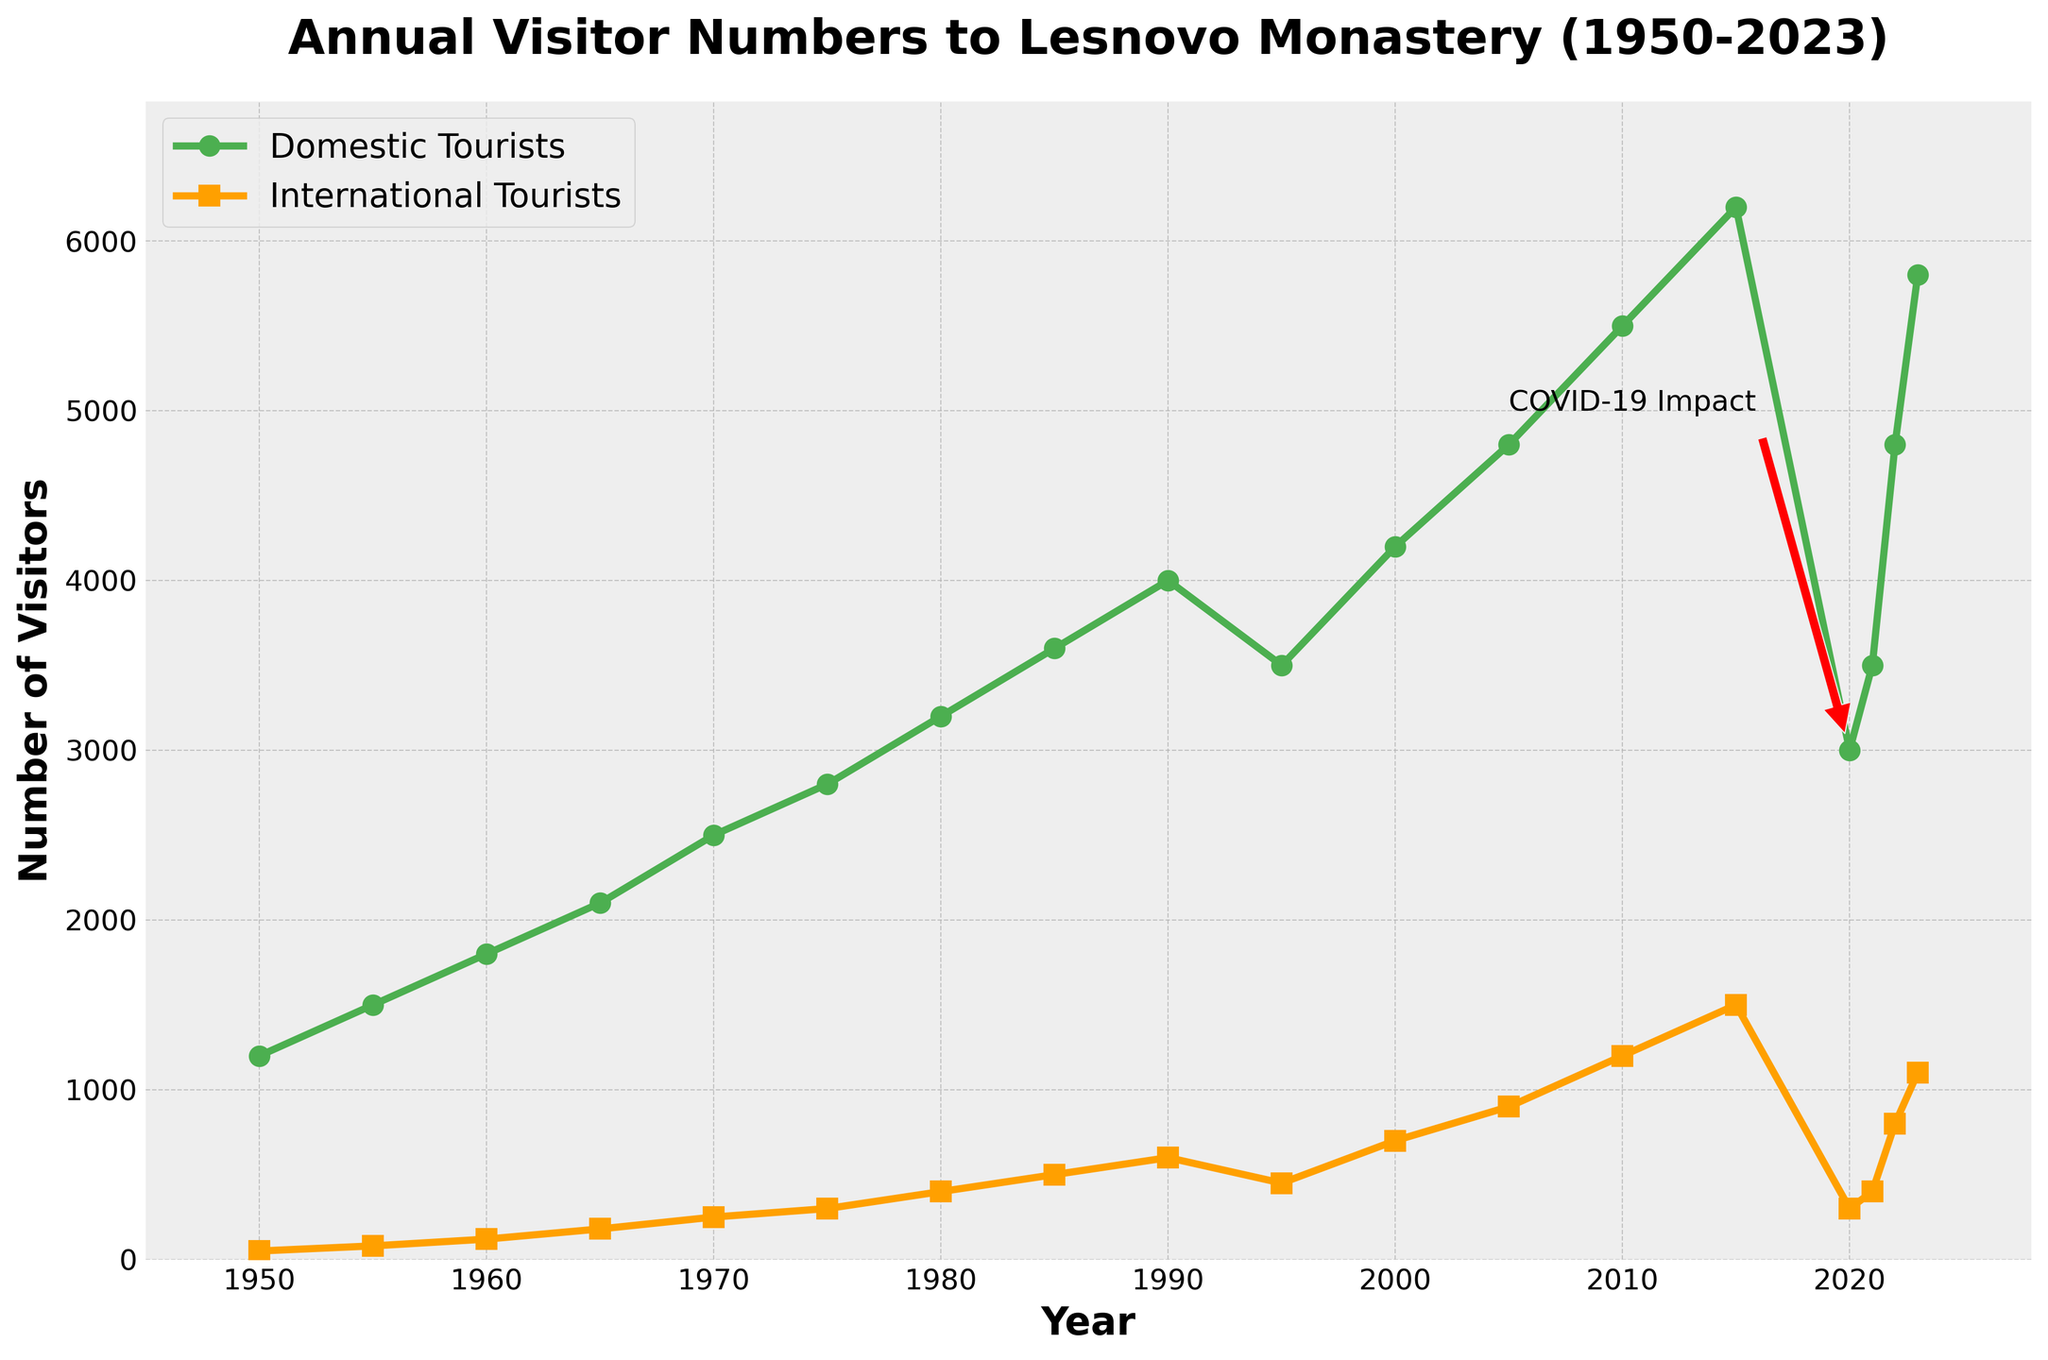How has the number of domestic tourists changed from 1950 to 2023? In 1950, the number of domestic tourists was 1200, and in 2023, it was 5800. To find the change, subtract the 1950 value from the 2023 value: 5800 - 1200 = 4600. Therefore, the number has increased by 4600.
Answer: 4600 Which year observed the highest number of international tourists? The highest point on the international tourists' line on the graph is at 2023, where the number reaches 1100.
Answer: 2023 How does the number of international tourists in 1970 compare with the number in 1980? In 1970, the number of international tourists was 250, and in 1980, it was 400. By comparing these values, it is clear that the number of international tourists increased from 1970 to 1980.
Answer: Increased What visual elements highlight the impact of COVID-19 on visitor numbers? The annotation "COVID-19 Impact" along with an arrow pointing to the steep drop in both domestic and international tourists around 2020 represents the impact visually.
Answer: Annotation and arrow indicating the drop in 2020 What is the average number of domestic tourists in the decades of the 2000s (2000-2009) and the 2010s (2010-2019)? For the 2000s, the data points are 4200 (2000) and 4800 (2005). Their average is (4200 + 4800) / 2 = 4500. For the 2010s, the data points are 5500 (2010) and 6200 (2015), so the average is (5500 + 6200) / 2 = 5850.
Answer: 4500 and 5850 By what percentage did the number of domestic tourists decline from 2015 to 2020, and how did it recover in 2023? In 2015, the number of domestic tourists was 6200. In 2020, it was 3000, which is a decline of 3200. The percentage decline is (3200 / 6200) * 100 ≈ 51.61%. In 2023, the figure recovered to 5800; the increase from 2020 to 2023 is 2800.
Answer: 51.61% decline and 2800 recovery Compare the trend of domestic visitors and international visitors from 1950 to 2023. The number of domestic tourists shows a general upward trend with periodic fluctuations and a noticeable drop around 2020. The number of international tourists gradually increases overall, with smaller fluctuations, and also drops around 2020 but less steeply.
Answer: Upward trends with a dip in 2020 Which category of tourists recovered faster after the dip in 2020? Comparing the numbers from 2020 to 2023, domestic tourists went from 3000 to 5800 (an increase of 2800), and international tourists increased from 300 to 1100 (an increase of 800). Thus, domestic tourists recovered faster.
Answer: Domestic tourists What does the length and number of the markers on the lines in the plot indicate? The markers along the lines indicate specific data points plotted against the years. Their frequencies and placements mark the data values for domestic and international tourist numbers at given intervals.
Answer: Data points along the timeline 